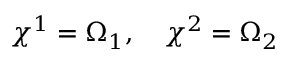Convert formula to latex. <formula><loc_0><loc_0><loc_500><loc_500>\chi ^ { 1 } = \Omega _ { 1 } , \chi ^ { 2 } = \Omega _ { 2 }</formula> 